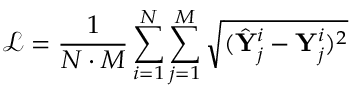Convert formula to latex. <formula><loc_0><loc_0><loc_500><loc_500>\mathcal { L } = \frac { 1 } { N \cdot M } \sum _ { i = 1 } ^ { N } { \sum _ { j = 1 } ^ { M } { \sqrt { ( \hat { Y } _ { j } ^ { i } - Y _ { j } ^ { i } ) ^ { 2 } } } }</formula> 